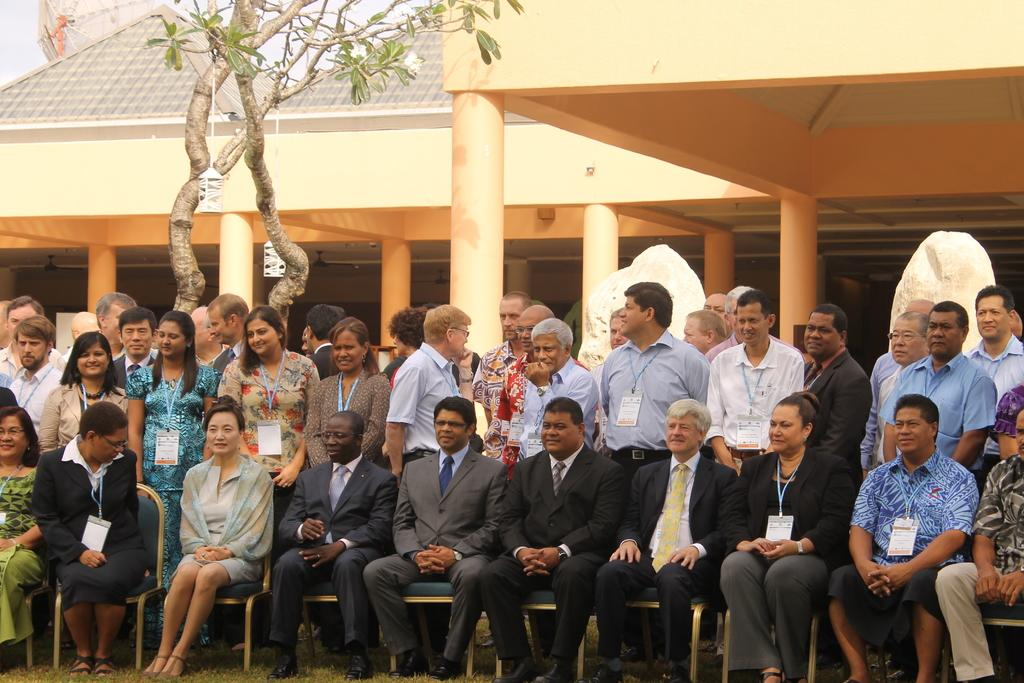What is happening in the image? There is a group of people in the image. Can you describe the positions of the people? The people are sitting and standing. What can be seen in the background of the image? There is a building and a tree in the background of the image. What type of market is visible in the image? There is no market present in the image; it features a group of people, a building, and a tree in the background. What country is the image taken in? The country where the image was taken is not mentioned in the provided facts. 